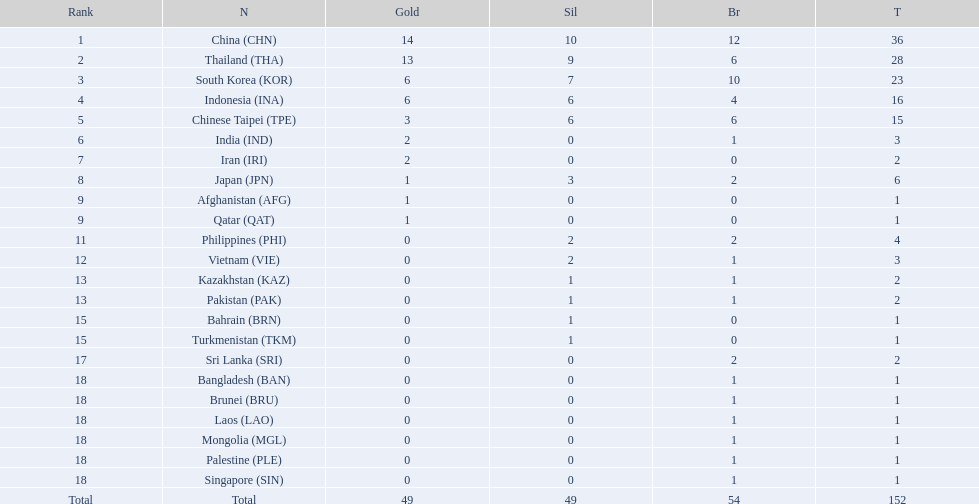How many more medals did india earn compared to pakistan? 1. 